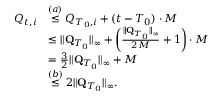Convert formula to latex. <formula><loc_0><loc_0><loc_500><loc_500>\begin{array} { r l } { Q _ { t , i } } & { \stackrel { ( a ) } \leq Q _ { T _ { 0 } , i } + ( t - T _ { 0 } ) \cdot M } \\ & { \leq \| \mathbf Q _ { T _ { 0 } } \| _ { \infty } + \left ( \frac { \| \mathbf Q _ { T _ { 0 } } \| _ { \infty } } { 2 M } + 1 \right ) \cdot M } \\ & { = \frac { 3 } { 2 } \| \mathbf Q _ { T _ { 0 } } \| _ { \infty } + M } \\ & { \stackrel { ( b ) } \leq 2 \| \mathbf Q _ { T _ { 0 } } \| _ { \infty } . } \end{array}</formula> 